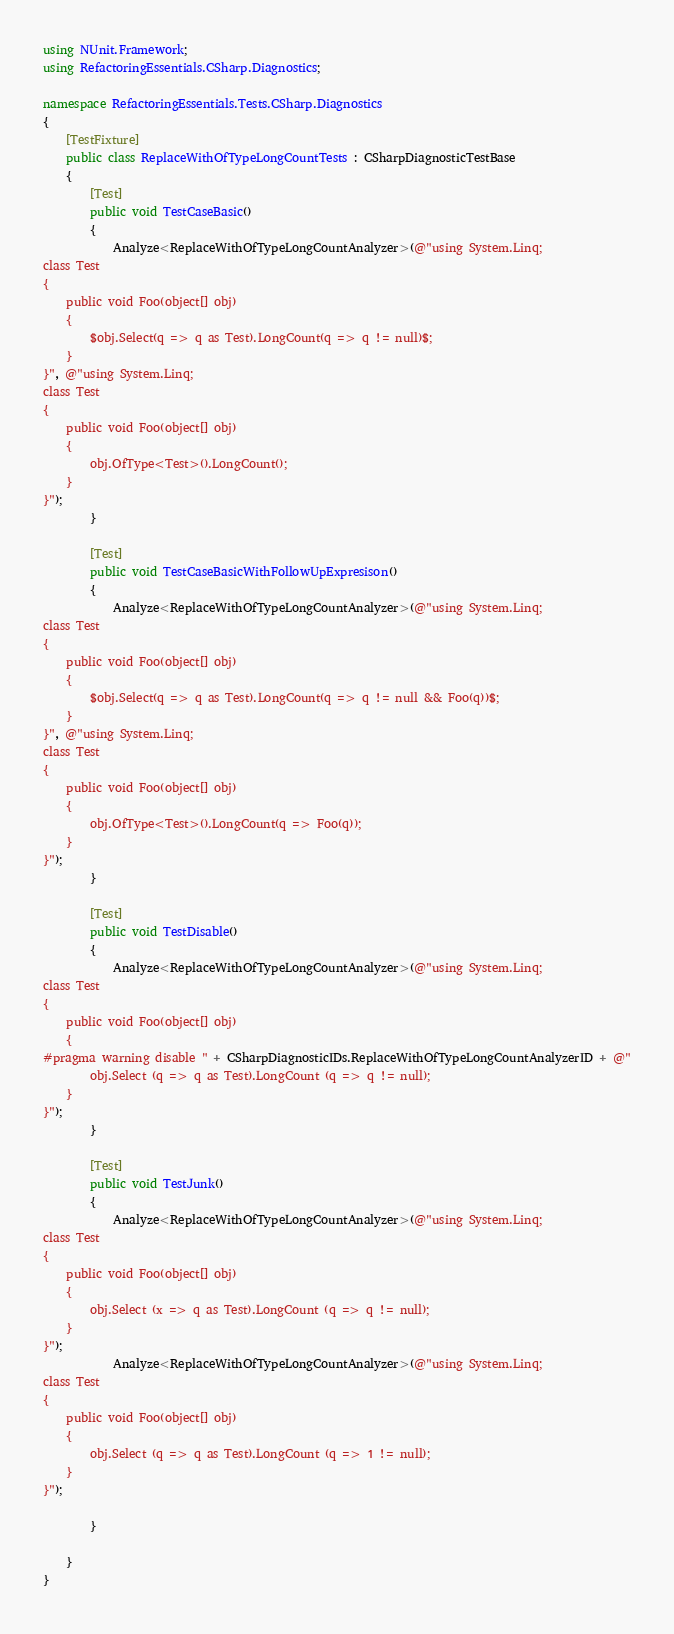Convert code to text. <code><loc_0><loc_0><loc_500><loc_500><_C#_>using NUnit.Framework;
using RefactoringEssentials.CSharp.Diagnostics;

namespace RefactoringEssentials.Tests.CSharp.Diagnostics
{
    [TestFixture]
    public class ReplaceWithOfTypeLongCountTests : CSharpDiagnosticTestBase
    {
        [Test]
        public void TestCaseBasic()
        {
            Analyze<ReplaceWithOfTypeLongCountAnalyzer>(@"using System.Linq;
class Test
{
    public void Foo(object[] obj)
    {
        $obj.Select(q => q as Test).LongCount(q => q != null)$;
    }
}", @"using System.Linq;
class Test
{
    public void Foo(object[] obj)
    {
        obj.OfType<Test>().LongCount();
    }
}");
        }

        [Test]
        public void TestCaseBasicWithFollowUpExpresison()
        {
            Analyze<ReplaceWithOfTypeLongCountAnalyzer>(@"using System.Linq;
class Test
{
    public void Foo(object[] obj)
    {
        $obj.Select(q => q as Test).LongCount(q => q != null && Foo(q))$;
    }
}", @"using System.Linq;
class Test
{
    public void Foo(object[] obj)
    {
        obj.OfType<Test>().LongCount(q => Foo(q));
    }
}");
        }

        [Test]
        public void TestDisable()
        {
            Analyze<ReplaceWithOfTypeLongCountAnalyzer>(@"using System.Linq;
class Test
{
	public void Foo(object[] obj)
	{
#pragma warning disable " + CSharpDiagnosticIDs.ReplaceWithOfTypeLongCountAnalyzerID + @"
		obj.Select (q => q as Test).LongCount (q => q != null);
	}
}");
        }

        [Test]
        public void TestJunk()
        {
            Analyze<ReplaceWithOfTypeLongCountAnalyzer>(@"using System.Linq;
class Test
{
	public void Foo(object[] obj)
	{
		obj.Select (x => q as Test).LongCount (q => q != null);
	}
}");
            Analyze<ReplaceWithOfTypeLongCountAnalyzer>(@"using System.Linq;
class Test
{
	public void Foo(object[] obj)
	{
		obj.Select (q => q as Test).LongCount (q => 1 != null);
	}
}");

        }

    }
}

</code> 